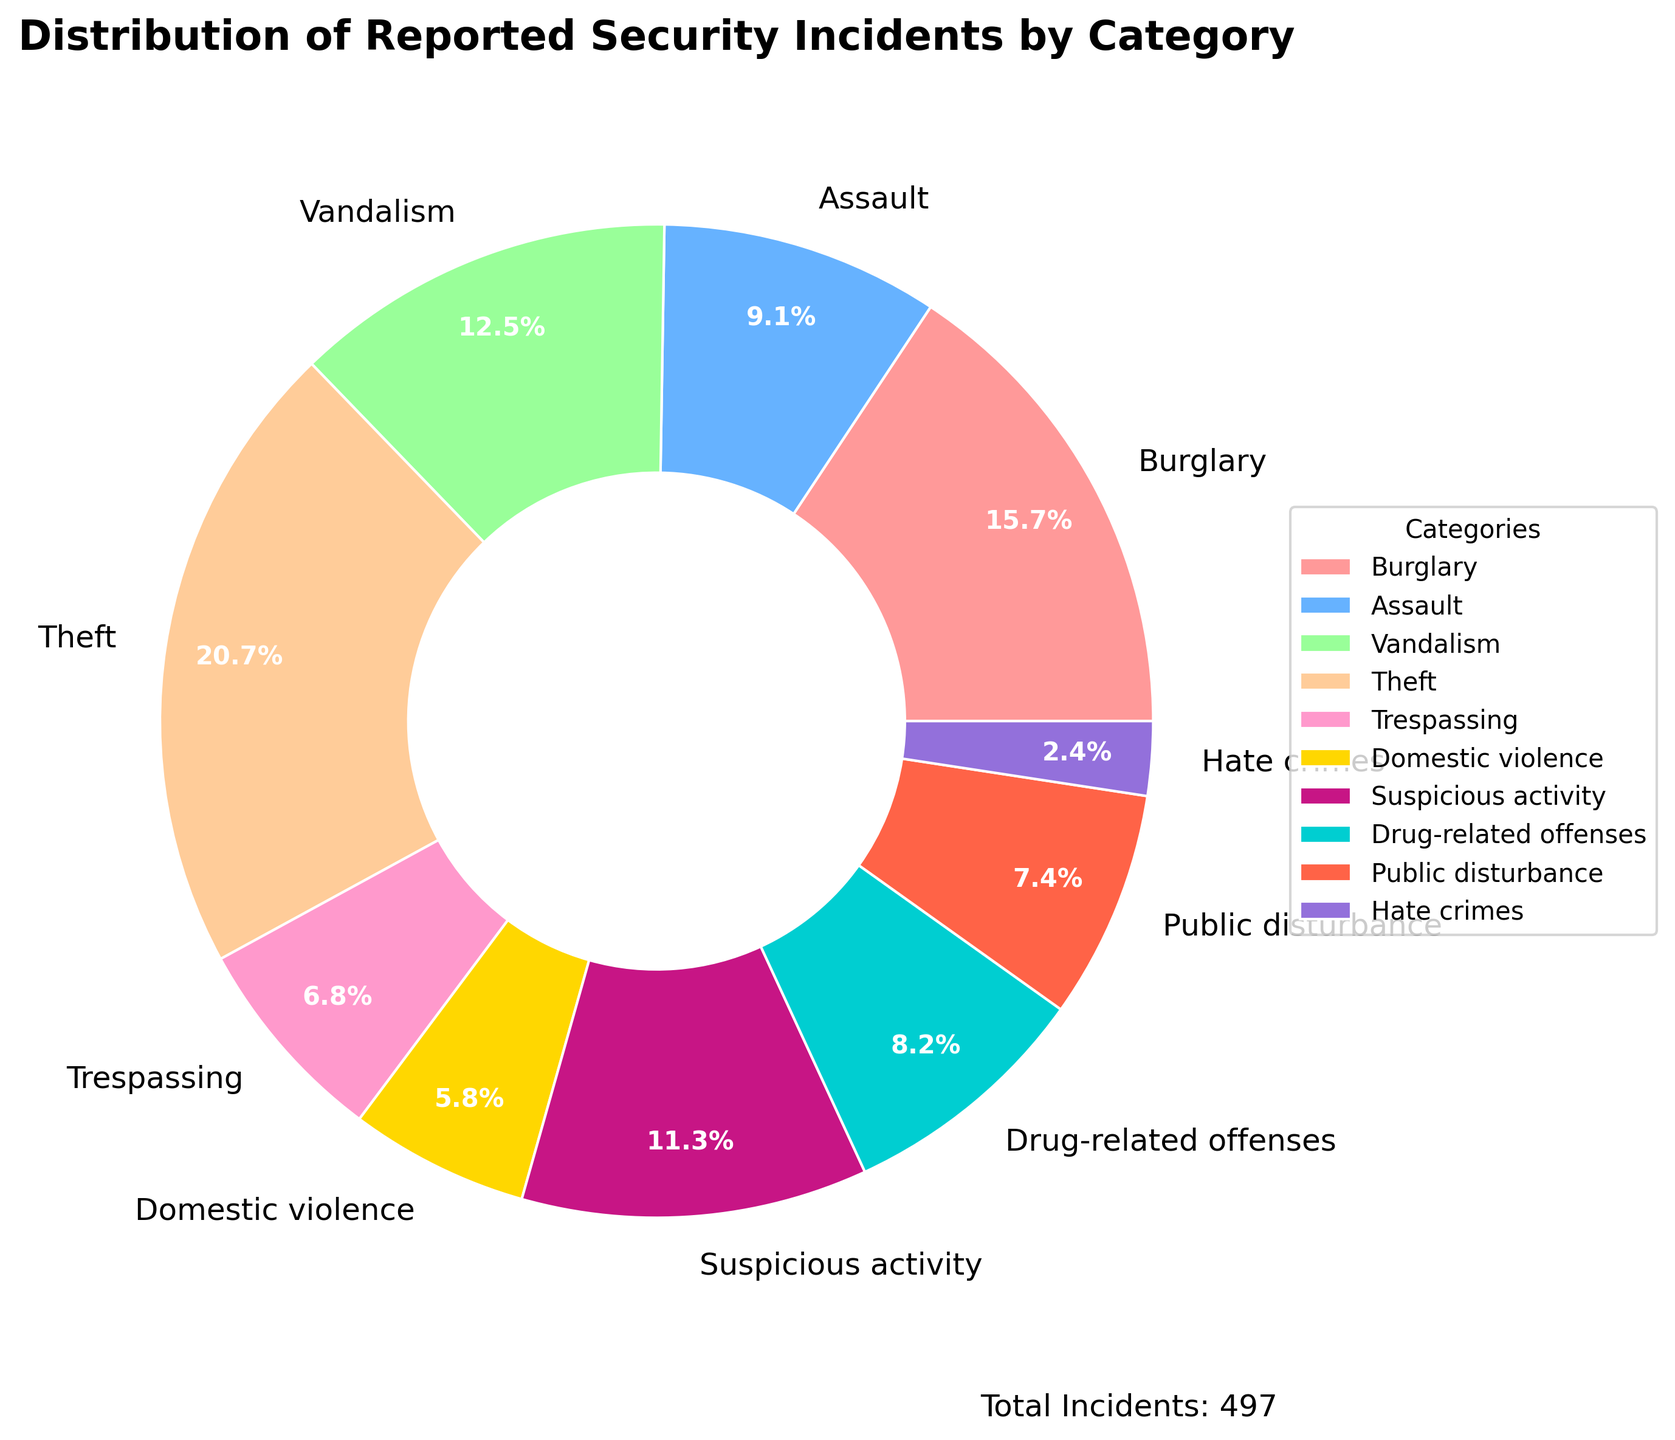What's the percentage share of Theft incidents? Find the section in the pie chart labeled "Theft" and read the percentage next to it.
Answer: 20.9% Which category has the least number of incidents? Locate the smallest wedge in the pie chart and check the label, which corresponds to "Hate crimes."
Answer: Hate crimes What categories have a larger percentage of incidents compared to Vandalism? Identify the percentage of Vandalism (16.0%) and then look for wedges with a higher percentage. These categories are Theft (20.9%) and Burglary (15.8%).
Answer: Theft, Burglary What is the combined percentage of drug-related offenses and public disturbance incidents? Find the percentage for Drug-related offenses (8.3%) and Public disturbance (7.5%). Add them together: 8.3% + 7.5% = 15.8%.
Answer: 15.8% What is the difference in the number of incidents between Burglary and Domestic violence? Burglary has 78 incidents, while Domestic violence has 29. Subtract 29 from 78: 78 - 29 = 49.
Answer: 49 Which category appears in a dark purple wedge? Visual inspection of the wedge's color shows that Drug-related offenses appear in a dark purple.
Answer: Drug-related offenses How many total categories are reported in the pie chart? Count the labels corresponding to the wedges in the pie chart.
Answer: 10 What's the total percentage share of Assault and Suspicious activity? Identify the percentage for Assault (9.1%) and Suspicious activity (11.3%). Add them together: 9.1% + 11.3% = 20.4%.
Answer: 20.4% Which category has more incidents: Public disturbance or Trespassing? Compare the number of incidents: Public disturbance has 37, while Trespassing has 34. Therefore, Public disturbance has more incidents.
Answer: Public disturbance What is the difference in percentage between Hate crimes and Theft? Hate crimes have 2.4% while Theft has 20.9%. Subtract the two percentages: 20.9% - 2.4% = 18.5%.
Answer: 18.5% 